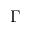<formula> <loc_0><loc_0><loc_500><loc_500>\Gamma</formula> 